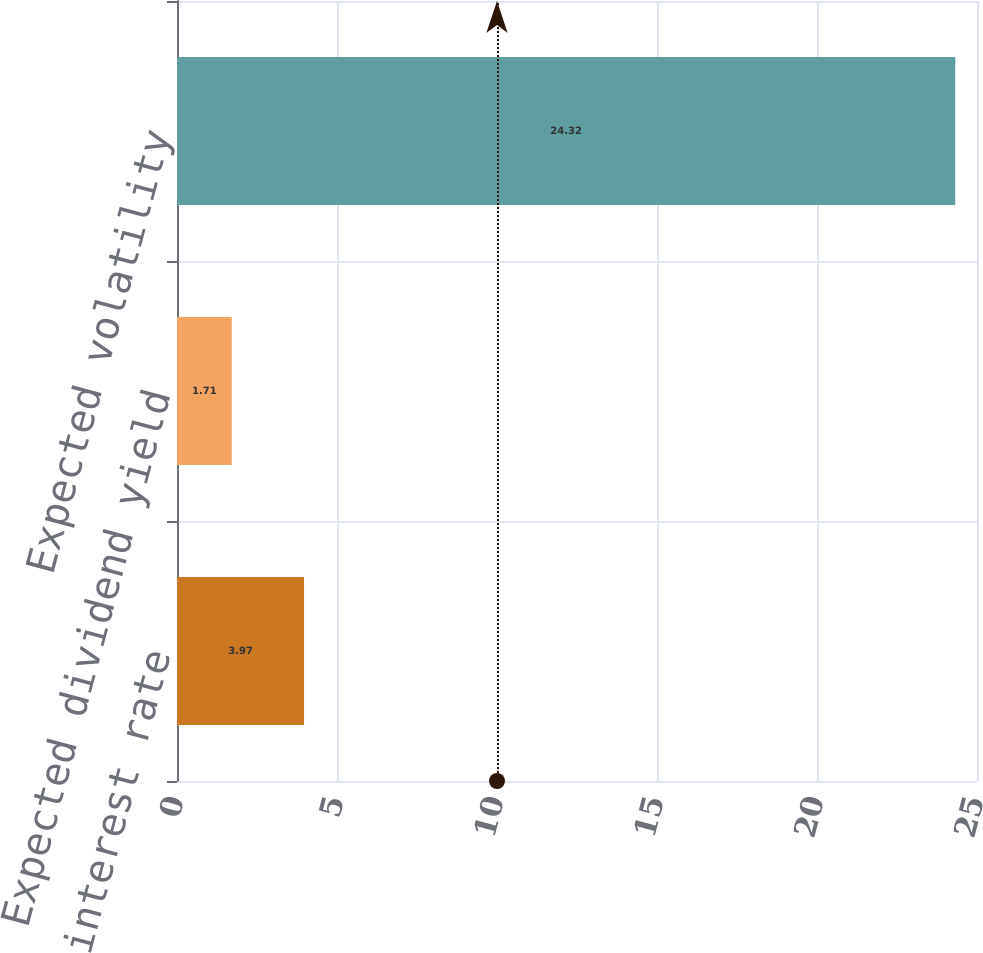<chart> <loc_0><loc_0><loc_500><loc_500><bar_chart><fcel>Risk-free interest rate<fcel>Expected dividend yield<fcel>Expected volatility<nl><fcel>3.97<fcel>1.71<fcel>24.32<nl></chart> 